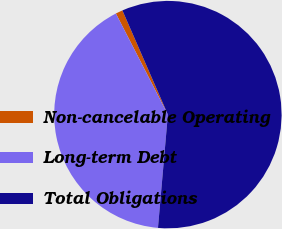<chart> <loc_0><loc_0><loc_500><loc_500><pie_chart><fcel>Non-cancelable Operating<fcel>Long-term Debt<fcel>Total Obligations<nl><fcel>1.01%<fcel>41.05%<fcel>57.94%<nl></chart> 